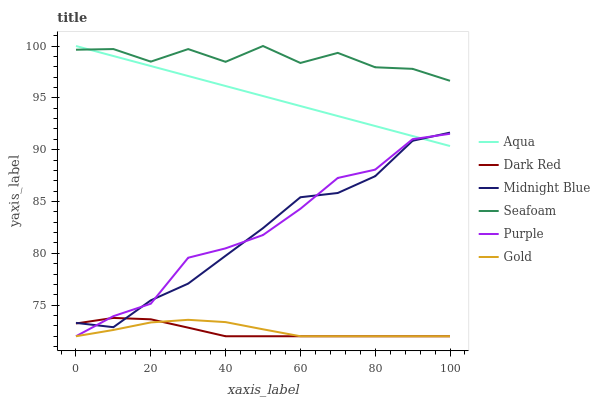Does Dark Red have the minimum area under the curve?
Answer yes or no. Yes. Does Seafoam have the maximum area under the curve?
Answer yes or no. Yes. Does Gold have the minimum area under the curve?
Answer yes or no. No. Does Gold have the maximum area under the curve?
Answer yes or no. No. Is Aqua the smoothest?
Answer yes or no. Yes. Is Seafoam the roughest?
Answer yes or no. Yes. Is Gold the smoothest?
Answer yes or no. No. Is Gold the roughest?
Answer yes or no. No. Does Gold have the lowest value?
Answer yes or no. Yes. Does Aqua have the lowest value?
Answer yes or no. No. Does Seafoam have the highest value?
Answer yes or no. Yes. Does Purple have the highest value?
Answer yes or no. No. Is Midnight Blue less than Seafoam?
Answer yes or no. Yes. Is Aqua greater than Dark Red?
Answer yes or no. Yes. Does Midnight Blue intersect Aqua?
Answer yes or no. Yes. Is Midnight Blue less than Aqua?
Answer yes or no. No. Is Midnight Blue greater than Aqua?
Answer yes or no. No. Does Midnight Blue intersect Seafoam?
Answer yes or no. No. 